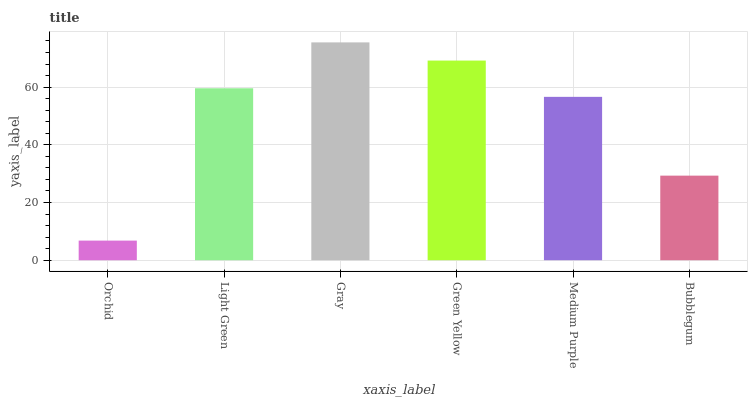Is Orchid the minimum?
Answer yes or no. Yes. Is Gray the maximum?
Answer yes or no. Yes. Is Light Green the minimum?
Answer yes or no. No. Is Light Green the maximum?
Answer yes or no. No. Is Light Green greater than Orchid?
Answer yes or no. Yes. Is Orchid less than Light Green?
Answer yes or no. Yes. Is Orchid greater than Light Green?
Answer yes or no. No. Is Light Green less than Orchid?
Answer yes or no. No. Is Light Green the high median?
Answer yes or no. Yes. Is Medium Purple the low median?
Answer yes or no. Yes. Is Bubblegum the high median?
Answer yes or no. No. Is Orchid the low median?
Answer yes or no. No. 